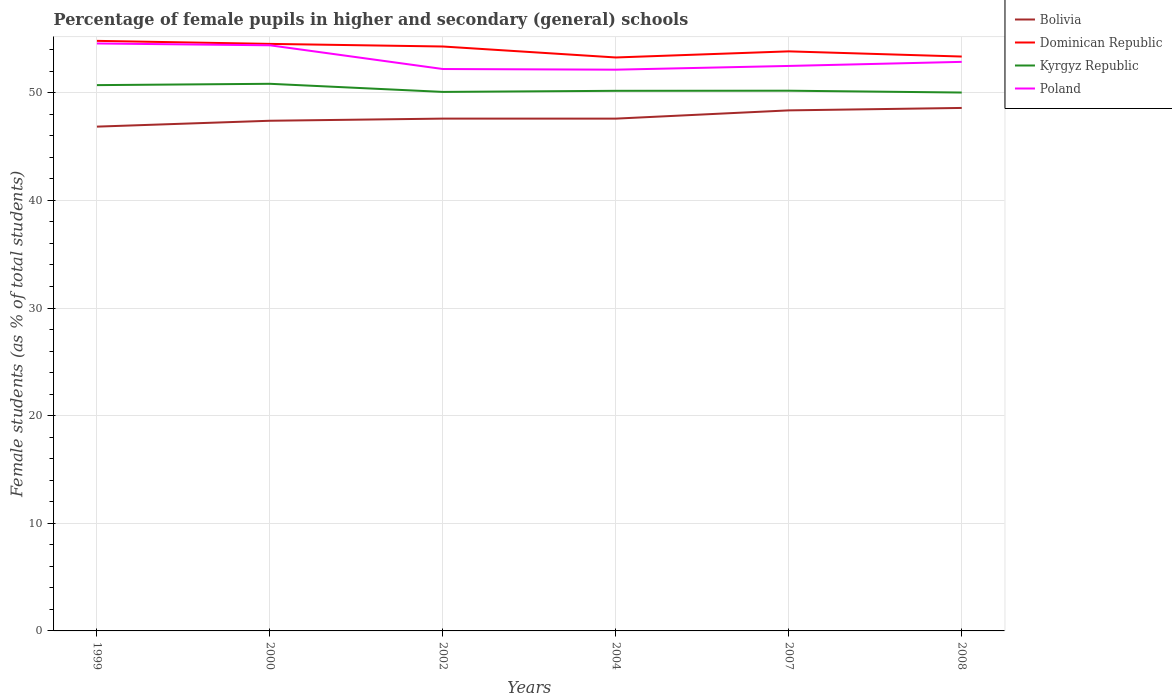Does the line corresponding to Dominican Republic intersect with the line corresponding to Poland?
Provide a succinct answer. No. Across all years, what is the maximum percentage of female pupils in higher and secondary schools in Bolivia?
Keep it short and to the point. 46.85. In which year was the percentage of female pupils in higher and secondary schools in Bolivia maximum?
Offer a very short reply. 1999. What is the total percentage of female pupils in higher and secondary schools in Poland in the graph?
Offer a terse response. 0.06. What is the difference between the highest and the second highest percentage of female pupils in higher and secondary schools in Kyrgyz Republic?
Offer a very short reply. 0.81. Is the percentage of female pupils in higher and secondary schools in Poland strictly greater than the percentage of female pupils in higher and secondary schools in Kyrgyz Republic over the years?
Keep it short and to the point. No. How many lines are there?
Your answer should be compact. 4. How many years are there in the graph?
Provide a short and direct response. 6. What is the difference between two consecutive major ticks on the Y-axis?
Your answer should be compact. 10. Are the values on the major ticks of Y-axis written in scientific E-notation?
Your response must be concise. No. Does the graph contain grids?
Give a very brief answer. Yes. Where does the legend appear in the graph?
Make the answer very short. Top right. How many legend labels are there?
Your answer should be compact. 4. What is the title of the graph?
Keep it short and to the point. Percentage of female pupils in higher and secondary (general) schools. Does "Kyrgyz Republic" appear as one of the legend labels in the graph?
Your answer should be very brief. Yes. What is the label or title of the X-axis?
Your response must be concise. Years. What is the label or title of the Y-axis?
Keep it short and to the point. Female students (as % of total students). What is the Female students (as % of total students) in Bolivia in 1999?
Your answer should be compact. 46.85. What is the Female students (as % of total students) of Dominican Republic in 1999?
Your response must be concise. 54.82. What is the Female students (as % of total students) in Kyrgyz Republic in 1999?
Provide a short and direct response. 50.71. What is the Female students (as % of total students) of Poland in 1999?
Your answer should be compact. 54.58. What is the Female students (as % of total students) of Bolivia in 2000?
Make the answer very short. 47.4. What is the Female students (as % of total students) in Dominican Republic in 2000?
Provide a succinct answer. 54.54. What is the Female students (as % of total students) of Kyrgyz Republic in 2000?
Offer a very short reply. 50.83. What is the Female students (as % of total students) in Poland in 2000?
Ensure brevity in your answer.  54.41. What is the Female students (as % of total students) in Bolivia in 2002?
Provide a succinct answer. 47.6. What is the Female students (as % of total students) in Dominican Republic in 2002?
Offer a terse response. 54.3. What is the Female students (as % of total students) of Kyrgyz Republic in 2002?
Offer a very short reply. 50.08. What is the Female students (as % of total students) in Poland in 2002?
Ensure brevity in your answer.  52.21. What is the Female students (as % of total students) in Bolivia in 2004?
Ensure brevity in your answer.  47.6. What is the Female students (as % of total students) in Dominican Republic in 2004?
Provide a short and direct response. 53.28. What is the Female students (as % of total students) in Kyrgyz Republic in 2004?
Keep it short and to the point. 50.18. What is the Female students (as % of total students) in Poland in 2004?
Give a very brief answer. 52.15. What is the Female students (as % of total students) of Bolivia in 2007?
Offer a terse response. 48.36. What is the Female students (as % of total students) of Dominican Republic in 2007?
Your response must be concise. 53.85. What is the Female students (as % of total students) of Kyrgyz Republic in 2007?
Offer a very short reply. 50.19. What is the Female students (as % of total students) in Poland in 2007?
Offer a very short reply. 52.49. What is the Female students (as % of total students) in Bolivia in 2008?
Provide a short and direct response. 48.59. What is the Female students (as % of total students) in Dominican Republic in 2008?
Offer a terse response. 53.37. What is the Female students (as % of total students) of Kyrgyz Republic in 2008?
Your response must be concise. 50.02. What is the Female students (as % of total students) of Poland in 2008?
Give a very brief answer. 52.87. Across all years, what is the maximum Female students (as % of total students) in Bolivia?
Offer a very short reply. 48.59. Across all years, what is the maximum Female students (as % of total students) of Dominican Republic?
Provide a succinct answer. 54.82. Across all years, what is the maximum Female students (as % of total students) of Kyrgyz Republic?
Provide a succinct answer. 50.83. Across all years, what is the maximum Female students (as % of total students) in Poland?
Offer a very short reply. 54.58. Across all years, what is the minimum Female students (as % of total students) of Bolivia?
Ensure brevity in your answer.  46.85. Across all years, what is the minimum Female students (as % of total students) in Dominican Republic?
Give a very brief answer. 53.28. Across all years, what is the minimum Female students (as % of total students) of Kyrgyz Republic?
Provide a short and direct response. 50.02. Across all years, what is the minimum Female students (as % of total students) of Poland?
Offer a terse response. 52.15. What is the total Female students (as % of total students) in Bolivia in the graph?
Your answer should be very brief. 286.41. What is the total Female students (as % of total students) in Dominican Republic in the graph?
Your answer should be very brief. 324.16. What is the total Female students (as % of total students) of Kyrgyz Republic in the graph?
Make the answer very short. 302.02. What is the total Female students (as % of total students) in Poland in the graph?
Offer a terse response. 318.71. What is the difference between the Female students (as % of total students) in Bolivia in 1999 and that in 2000?
Your answer should be very brief. -0.55. What is the difference between the Female students (as % of total students) in Dominican Republic in 1999 and that in 2000?
Offer a terse response. 0.28. What is the difference between the Female students (as % of total students) of Kyrgyz Republic in 1999 and that in 2000?
Offer a very short reply. -0.12. What is the difference between the Female students (as % of total students) of Poland in 1999 and that in 2000?
Make the answer very short. 0.17. What is the difference between the Female students (as % of total students) in Bolivia in 1999 and that in 2002?
Make the answer very short. -0.75. What is the difference between the Female students (as % of total students) of Dominican Republic in 1999 and that in 2002?
Provide a succinct answer. 0.52. What is the difference between the Female students (as % of total students) in Kyrgyz Republic in 1999 and that in 2002?
Ensure brevity in your answer.  0.63. What is the difference between the Female students (as % of total students) of Poland in 1999 and that in 2002?
Give a very brief answer. 2.37. What is the difference between the Female students (as % of total students) in Bolivia in 1999 and that in 2004?
Your answer should be very brief. -0.74. What is the difference between the Female students (as % of total students) in Dominican Republic in 1999 and that in 2004?
Your answer should be very brief. 1.54. What is the difference between the Female students (as % of total students) of Kyrgyz Republic in 1999 and that in 2004?
Keep it short and to the point. 0.53. What is the difference between the Female students (as % of total students) in Poland in 1999 and that in 2004?
Offer a terse response. 2.43. What is the difference between the Female students (as % of total students) of Bolivia in 1999 and that in 2007?
Your answer should be compact. -1.51. What is the difference between the Female students (as % of total students) in Dominican Republic in 1999 and that in 2007?
Your answer should be very brief. 0.98. What is the difference between the Female students (as % of total students) of Kyrgyz Republic in 1999 and that in 2007?
Ensure brevity in your answer.  0.52. What is the difference between the Female students (as % of total students) of Poland in 1999 and that in 2007?
Offer a terse response. 2.09. What is the difference between the Female students (as % of total students) in Bolivia in 1999 and that in 2008?
Provide a succinct answer. -1.74. What is the difference between the Female students (as % of total students) in Dominican Republic in 1999 and that in 2008?
Your answer should be very brief. 1.46. What is the difference between the Female students (as % of total students) in Kyrgyz Republic in 1999 and that in 2008?
Make the answer very short. 0.69. What is the difference between the Female students (as % of total students) of Poland in 1999 and that in 2008?
Ensure brevity in your answer.  1.71. What is the difference between the Female students (as % of total students) in Bolivia in 2000 and that in 2002?
Make the answer very short. -0.2. What is the difference between the Female students (as % of total students) of Dominican Republic in 2000 and that in 2002?
Ensure brevity in your answer.  0.24. What is the difference between the Female students (as % of total students) of Kyrgyz Republic in 2000 and that in 2002?
Ensure brevity in your answer.  0.75. What is the difference between the Female students (as % of total students) of Poland in 2000 and that in 2002?
Offer a terse response. 2.2. What is the difference between the Female students (as % of total students) of Bolivia in 2000 and that in 2004?
Your answer should be compact. -0.2. What is the difference between the Female students (as % of total students) of Dominican Republic in 2000 and that in 2004?
Provide a short and direct response. 1.26. What is the difference between the Female students (as % of total students) of Kyrgyz Republic in 2000 and that in 2004?
Your answer should be very brief. 0.65. What is the difference between the Female students (as % of total students) of Poland in 2000 and that in 2004?
Your response must be concise. 2.27. What is the difference between the Female students (as % of total students) of Bolivia in 2000 and that in 2007?
Your answer should be very brief. -0.96. What is the difference between the Female students (as % of total students) in Dominican Republic in 2000 and that in 2007?
Offer a terse response. 0.69. What is the difference between the Female students (as % of total students) of Kyrgyz Republic in 2000 and that in 2007?
Ensure brevity in your answer.  0.64. What is the difference between the Female students (as % of total students) of Poland in 2000 and that in 2007?
Ensure brevity in your answer.  1.92. What is the difference between the Female students (as % of total students) of Bolivia in 2000 and that in 2008?
Offer a terse response. -1.19. What is the difference between the Female students (as % of total students) in Dominican Republic in 2000 and that in 2008?
Provide a short and direct response. 1.18. What is the difference between the Female students (as % of total students) in Kyrgyz Republic in 2000 and that in 2008?
Your answer should be very brief. 0.81. What is the difference between the Female students (as % of total students) in Poland in 2000 and that in 2008?
Offer a terse response. 1.54. What is the difference between the Female students (as % of total students) in Bolivia in 2002 and that in 2004?
Provide a succinct answer. 0. What is the difference between the Female students (as % of total students) of Dominican Republic in 2002 and that in 2004?
Provide a short and direct response. 1.02. What is the difference between the Female students (as % of total students) in Kyrgyz Republic in 2002 and that in 2004?
Your answer should be very brief. -0.1. What is the difference between the Female students (as % of total students) of Poland in 2002 and that in 2004?
Keep it short and to the point. 0.06. What is the difference between the Female students (as % of total students) of Bolivia in 2002 and that in 2007?
Provide a succinct answer. -0.76. What is the difference between the Female students (as % of total students) in Dominican Republic in 2002 and that in 2007?
Provide a short and direct response. 0.45. What is the difference between the Female students (as % of total students) in Kyrgyz Republic in 2002 and that in 2007?
Your response must be concise. -0.11. What is the difference between the Female students (as % of total students) in Poland in 2002 and that in 2007?
Give a very brief answer. -0.29. What is the difference between the Female students (as % of total students) in Bolivia in 2002 and that in 2008?
Keep it short and to the point. -0.99. What is the difference between the Female students (as % of total students) in Dominican Republic in 2002 and that in 2008?
Offer a terse response. 0.93. What is the difference between the Female students (as % of total students) of Kyrgyz Republic in 2002 and that in 2008?
Offer a terse response. 0.06. What is the difference between the Female students (as % of total students) of Poland in 2002 and that in 2008?
Provide a short and direct response. -0.67. What is the difference between the Female students (as % of total students) in Bolivia in 2004 and that in 2007?
Offer a terse response. -0.77. What is the difference between the Female students (as % of total students) of Dominican Republic in 2004 and that in 2007?
Your answer should be compact. -0.57. What is the difference between the Female students (as % of total students) in Kyrgyz Republic in 2004 and that in 2007?
Keep it short and to the point. -0.01. What is the difference between the Female students (as % of total students) in Poland in 2004 and that in 2007?
Make the answer very short. -0.35. What is the difference between the Female students (as % of total students) of Bolivia in 2004 and that in 2008?
Keep it short and to the point. -0.99. What is the difference between the Female students (as % of total students) of Dominican Republic in 2004 and that in 2008?
Make the answer very short. -0.09. What is the difference between the Female students (as % of total students) in Kyrgyz Republic in 2004 and that in 2008?
Keep it short and to the point. 0.16. What is the difference between the Female students (as % of total students) of Poland in 2004 and that in 2008?
Offer a very short reply. -0.73. What is the difference between the Female students (as % of total students) in Bolivia in 2007 and that in 2008?
Give a very brief answer. -0.23. What is the difference between the Female students (as % of total students) in Dominican Republic in 2007 and that in 2008?
Ensure brevity in your answer.  0.48. What is the difference between the Female students (as % of total students) in Kyrgyz Republic in 2007 and that in 2008?
Your response must be concise. 0.17. What is the difference between the Female students (as % of total students) in Poland in 2007 and that in 2008?
Provide a short and direct response. -0.38. What is the difference between the Female students (as % of total students) of Bolivia in 1999 and the Female students (as % of total students) of Dominican Republic in 2000?
Offer a very short reply. -7.69. What is the difference between the Female students (as % of total students) of Bolivia in 1999 and the Female students (as % of total students) of Kyrgyz Republic in 2000?
Provide a short and direct response. -3.98. What is the difference between the Female students (as % of total students) in Bolivia in 1999 and the Female students (as % of total students) in Poland in 2000?
Ensure brevity in your answer.  -7.56. What is the difference between the Female students (as % of total students) of Dominican Republic in 1999 and the Female students (as % of total students) of Kyrgyz Republic in 2000?
Keep it short and to the point. 3.99. What is the difference between the Female students (as % of total students) of Dominican Republic in 1999 and the Female students (as % of total students) of Poland in 2000?
Provide a short and direct response. 0.41. What is the difference between the Female students (as % of total students) in Kyrgyz Republic in 1999 and the Female students (as % of total students) in Poland in 2000?
Make the answer very short. -3.7. What is the difference between the Female students (as % of total students) of Bolivia in 1999 and the Female students (as % of total students) of Dominican Republic in 2002?
Your answer should be very brief. -7.44. What is the difference between the Female students (as % of total students) of Bolivia in 1999 and the Female students (as % of total students) of Kyrgyz Republic in 2002?
Provide a short and direct response. -3.23. What is the difference between the Female students (as % of total students) in Bolivia in 1999 and the Female students (as % of total students) in Poland in 2002?
Offer a very short reply. -5.35. What is the difference between the Female students (as % of total students) in Dominican Republic in 1999 and the Female students (as % of total students) in Kyrgyz Republic in 2002?
Offer a very short reply. 4.74. What is the difference between the Female students (as % of total students) in Dominican Republic in 1999 and the Female students (as % of total students) in Poland in 2002?
Your answer should be compact. 2.62. What is the difference between the Female students (as % of total students) of Kyrgyz Republic in 1999 and the Female students (as % of total students) of Poland in 2002?
Your response must be concise. -1.5. What is the difference between the Female students (as % of total students) of Bolivia in 1999 and the Female students (as % of total students) of Dominican Republic in 2004?
Your answer should be very brief. -6.43. What is the difference between the Female students (as % of total students) of Bolivia in 1999 and the Female students (as % of total students) of Kyrgyz Republic in 2004?
Keep it short and to the point. -3.33. What is the difference between the Female students (as % of total students) of Bolivia in 1999 and the Female students (as % of total students) of Poland in 2004?
Provide a short and direct response. -5.29. What is the difference between the Female students (as % of total students) in Dominican Republic in 1999 and the Female students (as % of total students) in Kyrgyz Republic in 2004?
Keep it short and to the point. 4.64. What is the difference between the Female students (as % of total students) of Dominican Republic in 1999 and the Female students (as % of total students) of Poland in 2004?
Make the answer very short. 2.68. What is the difference between the Female students (as % of total students) of Kyrgyz Republic in 1999 and the Female students (as % of total students) of Poland in 2004?
Make the answer very short. -1.44. What is the difference between the Female students (as % of total students) in Bolivia in 1999 and the Female students (as % of total students) in Dominican Republic in 2007?
Your answer should be compact. -6.99. What is the difference between the Female students (as % of total students) in Bolivia in 1999 and the Female students (as % of total students) in Kyrgyz Republic in 2007?
Make the answer very short. -3.34. What is the difference between the Female students (as % of total students) in Bolivia in 1999 and the Female students (as % of total students) in Poland in 2007?
Make the answer very short. -5.64. What is the difference between the Female students (as % of total students) of Dominican Republic in 1999 and the Female students (as % of total students) of Kyrgyz Republic in 2007?
Your answer should be compact. 4.63. What is the difference between the Female students (as % of total students) in Dominican Republic in 1999 and the Female students (as % of total students) in Poland in 2007?
Your answer should be compact. 2.33. What is the difference between the Female students (as % of total students) of Kyrgyz Republic in 1999 and the Female students (as % of total students) of Poland in 2007?
Keep it short and to the point. -1.78. What is the difference between the Female students (as % of total students) in Bolivia in 1999 and the Female students (as % of total students) in Dominican Republic in 2008?
Make the answer very short. -6.51. What is the difference between the Female students (as % of total students) of Bolivia in 1999 and the Female students (as % of total students) of Kyrgyz Republic in 2008?
Make the answer very short. -3.17. What is the difference between the Female students (as % of total students) of Bolivia in 1999 and the Female students (as % of total students) of Poland in 2008?
Provide a succinct answer. -6.02. What is the difference between the Female students (as % of total students) in Dominican Republic in 1999 and the Female students (as % of total students) in Kyrgyz Republic in 2008?
Your response must be concise. 4.8. What is the difference between the Female students (as % of total students) in Dominican Republic in 1999 and the Female students (as % of total students) in Poland in 2008?
Provide a short and direct response. 1.95. What is the difference between the Female students (as % of total students) in Kyrgyz Republic in 1999 and the Female students (as % of total students) in Poland in 2008?
Keep it short and to the point. -2.16. What is the difference between the Female students (as % of total students) of Bolivia in 2000 and the Female students (as % of total students) of Dominican Republic in 2002?
Make the answer very short. -6.9. What is the difference between the Female students (as % of total students) of Bolivia in 2000 and the Female students (as % of total students) of Kyrgyz Republic in 2002?
Provide a succinct answer. -2.68. What is the difference between the Female students (as % of total students) in Bolivia in 2000 and the Female students (as % of total students) in Poland in 2002?
Provide a succinct answer. -4.81. What is the difference between the Female students (as % of total students) in Dominican Republic in 2000 and the Female students (as % of total students) in Kyrgyz Republic in 2002?
Ensure brevity in your answer.  4.46. What is the difference between the Female students (as % of total students) of Dominican Republic in 2000 and the Female students (as % of total students) of Poland in 2002?
Keep it short and to the point. 2.34. What is the difference between the Female students (as % of total students) of Kyrgyz Republic in 2000 and the Female students (as % of total students) of Poland in 2002?
Your answer should be compact. -1.37. What is the difference between the Female students (as % of total students) in Bolivia in 2000 and the Female students (as % of total students) in Dominican Republic in 2004?
Your response must be concise. -5.88. What is the difference between the Female students (as % of total students) of Bolivia in 2000 and the Female students (as % of total students) of Kyrgyz Republic in 2004?
Your response must be concise. -2.78. What is the difference between the Female students (as % of total students) in Bolivia in 2000 and the Female students (as % of total students) in Poland in 2004?
Provide a succinct answer. -4.75. What is the difference between the Female students (as % of total students) in Dominican Republic in 2000 and the Female students (as % of total students) in Kyrgyz Republic in 2004?
Offer a very short reply. 4.36. What is the difference between the Female students (as % of total students) of Dominican Republic in 2000 and the Female students (as % of total students) of Poland in 2004?
Keep it short and to the point. 2.4. What is the difference between the Female students (as % of total students) in Kyrgyz Republic in 2000 and the Female students (as % of total students) in Poland in 2004?
Your answer should be very brief. -1.31. What is the difference between the Female students (as % of total students) of Bolivia in 2000 and the Female students (as % of total students) of Dominican Republic in 2007?
Provide a short and direct response. -6.45. What is the difference between the Female students (as % of total students) in Bolivia in 2000 and the Female students (as % of total students) in Kyrgyz Republic in 2007?
Ensure brevity in your answer.  -2.79. What is the difference between the Female students (as % of total students) of Bolivia in 2000 and the Female students (as % of total students) of Poland in 2007?
Your answer should be very brief. -5.09. What is the difference between the Female students (as % of total students) of Dominican Republic in 2000 and the Female students (as % of total students) of Kyrgyz Republic in 2007?
Give a very brief answer. 4.35. What is the difference between the Female students (as % of total students) of Dominican Republic in 2000 and the Female students (as % of total students) of Poland in 2007?
Your response must be concise. 2.05. What is the difference between the Female students (as % of total students) in Kyrgyz Republic in 2000 and the Female students (as % of total students) in Poland in 2007?
Provide a short and direct response. -1.66. What is the difference between the Female students (as % of total students) of Bolivia in 2000 and the Female students (as % of total students) of Dominican Republic in 2008?
Your response must be concise. -5.97. What is the difference between the Female students (as % of total students) of Bolivia in 2000 and the Female students (as % of total students) of Kyrgyz Republic in 2008?
Keep it short and to the point. -2.62. What is the difference between the Female students (as % of total students) in Bolivia in 2000 and the Female students (as % of total students) in Poland in 2008?
Keep it short and to the point. -5.47. What is the difference between the Female students (as % of total students) in Dominican Republic in 2000 and the Female students (as % of total students) in Kyrgyz Republic in 2008?
Ensure brevity in your answer.  4.52. What is the difference between the Female students (as % of total students) in Dominican Republic in 2000 and the Female students (as % of total students) in Poland in 2008?
Your response must be concise. 1.67. What is the difference between the Female students (as % of total students) in Kyrgyz Republic in 2000 and the Female students (as % of total students) in Poland in 2008?
Provide a short and direct response. -2.04. What is the difference between the Female students (as % of total students) in Bolivia in 2002 and the Female students (as % of total students) in Dominican Republic in 2004?
Provide a short and direct response. -5.68. What is the difference between the Female students (as % of total students) of Bolivia in 2002 and the Female students (as % of total students) of Kyrgyz Republic in 2004?
Your response must be concise. -2.58. What is the difference between the Female students (as % of total students) in Bolivia in 2002 and the Female students (as % of total students) in Poland in 2004?
Your answer should be compact. -4.55. What is the difference between the Female students (as % of total students) in Dominican Republic in 2002 and the Female students (as % of total students) in Kyrgyz Republic in 2004?
Give a very brief answer. 4.12. What is the difference between the Female students (as % of total students) of Dominican Republic in 2002 and the Female students (as % of total students) of Poland in 2004?
Your answer should be very brief. 2.15. What is the difference between the Female students (as % of total students) in Kyrgyz Republic in 2002 and the Female students (as % of total students) in Poland in 2004?
Offer a terse response. -2.07. What is the difference between the Female students (as % of total students) of Bolivia in 2002 and the Female students (as % of total students) of Dominican Republic in 2007?
Your answer should be very brief. -6.25. What is the difference between the Female students (as % of total students) in Bolivia in 2002 and the Female students (as % of total students) in Kyrgyz Republic in 2007?
Offer a very short reply. -2.59. What is the difference between the Female students (as % of total students) in Bolivia in 2002 and the Female students (as % of total students) in Poland in 2007?
Offer a very short reply. -4.89. What is the difference between the Female students (as % of total students) of Dominican Republic in 2002 and the Female students (as % of total students) of Kyrgyz Republic in 2007?
Make the answer very short. 4.11. What is the difference between the Female students (as % of total students) of Dominican Republic in 2002 and the Female students (as % of total students) of Poland in 2007?
Keep it short and to the point. 1.81. What is the difference between the Female students (as % of total students) in Kyrgyz Republic in 2002 and the Female students (as % of total students) in Poland in 2007?
Your answer should be very brief. -2.41. What is the difference between the Female students (as % of total students) in Bolivia in 2002 and the Female students (as % of total students) in Dominican Republic in 2008?
Offer a very short reply. -5.77. What is the difference between the Female students (as % of total students) in Bolivia in 2002 and the Female students (as % of total students) in Kyrgyz Republic in 2008?
Provide a succinct answer. -2.42. What is the difference between the Female students (as % of total students) in Bolivia in 2002 and the Female students (as % of total students) in Poland in 2008?
Provide a short and direct response. -5.27. What is the difference between the Female students (as % of total students) of Dominican Republic in 2002 and the Female students (as % of total students) of Kyrgyz Republic in 2008?
Offer a terse response. 4.28. What is the difference between the Female students (as % of total students) in Dominican Republic in 2002 and the Female students (as % of total students) in Poland in 2008?
Your response must be concise. 1.43. What is the difference between the Female students (as % of total students) of Kyrgyz Republic in 2002 and the Female students (as % of total students) of Poland in 2008?
Your response must be concise. -2.79. What is the difference between the Female students (as % of total students) of Bolivia in 2004 and the Female students (as % of total students) of Dominican Republic in 2007?
Your answer should be compact. -6.25. What is the difference between the Female students (as % of total students) of Bolivia in 2004 and the Female students (as % of total students) of Kyrgyz Republic in 2007?
Your response must be concise. -2.59. What is the difference between the Female students (as % of total students) in Bolivia in 2004 and the Female students (as % of total students) in Poland in 2007?
Ensure brevity in your answer.  -4.9. What is the difference between the Female students (as % of total students) of Dominican Republic in 2004 and the Female students (as % of total students) of Kyrgyz Republic in 2007?
Make the answer very short. 3.09. What is the difference between the Female students (as % of total students) in Dominican Republic in 2004 and the Female students (as % of total students) in Poland in 2007?
Give a very brief answer. 0.79. What is the difference between the Female students (as % of total students) of Kyrgyz Republic in 2004 and the Female students (as % of total students) of Poland in 2007?
Your answer should be compact. -2.31. What is the difference between the Female students (as % of total students) in Bolivia in 2004 and the Female students (as % of total students) in Dominican Republic in 2008?
Your answer should be very brief. -5.77. What is the difference between the Female students (as % of total students) in Bolivia in 2004 and the Female students (as % of total students) in Kyrgyz Republic in 2008?
Offer a very short reply. -2.42. What is the difference between the Female students (as % of total students) in Bolivia in 2004 and the Female students (as % of total students) in Poland in 2008?
Give a very brief answer. -5.27. What is the difference between the Female students (as % of total students) in Dominican Republic in 2004 and the Female students (as % of total students) in Kyrgyz Republic in 2008?
Give a very brief answer. 3.26. What is the difference between the Female students (as % of total students) in Dominican Republic in 2004 and the Female students (as % of total students) in Poland in 2008?
Your answer should be very brief. 0.41. What is the difference between the Female students (as % of total students) in Kyrgyz Republic in 2004 and the Female students (as % of total students) in Poland in 2008?
Your answer should be very brief. -2.69. What is the difference between the Female students (as % of total students) in Bolivia in 2007 and the Female students (as % of total students) in Dominican Republic in 2008?
Offer a very short reply. -5. What is the difference between the Female students (as % of total students) in Bolivia in 2007 and the Female students (as % of total students) in Kyrgyz Republic in 2008?
Keep it short and to the point. -1.66. What is the difference between the Female students (as % of total students) in Bolivia in 2007 and the Female students (as % of total students) in Poland in 2008?
Your answer should be very brief. -4.51. What is the difference between the Female students (as % of total students) in Dominican Republic in 2007 and the Female students (as % of total students) in Kyrgyz Republic in 2008?
Provide a succinct answer. 3.83. What is the difference between the Female students (as % of total students) of Dominican Republic in 2007 and the Female students (as % of total students) of Poland in 2008?
Offer a terse response. 0.98. What is the difference between the Female students (as % of total students) of Kyrgyz Republic in 2007 and the Female students (as % of total students) of Poland in 2008?
Ensure brevity in your answer.  -2.68. What is the average Female students (as % of total students) of Bolivia per year?
Your response must be concise. 47.73. What is the average Female students (as % of total students) in Dominican Republic per year?
Offer a very short reply. 54.03. What is the average Female students (as % of total students) of Kyrgyz Republic per year?
Your answer should be compact. 50.34. What is the average Female students (as % of total students) of Poland per year?
Provide a short and direct response. 53.12. In the year 1999, what is the difference between the Female students (as % of total students) in Bolivia and Female students (as % of total students) in Dominican Republic?
Offer a terse response. -7.97. In the year 1999, what is the difference between the Female students (as % of total students) of Bolivia and Female students (as % of total students) of Kyrgyz Republic?
Your response must be concise. -3.86. In the year 1999, what is the difference between the Female students (as % of total students) in Bolivia and Female students (as % of total students) in Poland?
Your answer should be very brief. -7.73. In the year 1999, what is the difference between the Female students (as % of total students) of Dominican Republic and Female students (as % of total students) of Kyrgyz Republic?
Your answer should be compact. 4.11. In the year 1999, what is the difference between the Female students (as % of total students) in Dominican Republic and Female students (as % of total students) in Poland?
Offer a very short reply. 0.24. In the year 1999, what is the difference between the Female students (as % of total students) of Kyrgyz Republic and Female students (as % of total students) of Poland?
Keep it short and to the point. -3.87. In the year 2000, what is the difference between the Female students (as % of total students) of Bolivia and Female students (as % of total students) of Dominican Republic?
Provide a succinct answer. -7.14. In the year 2000, what is the difference between the Female students (as % of total students) of Bolivia and Female students (as % of total students) of Kyrgyz Republic?
Offer a very short reply. -3.43. In the year 2000, what is the difference between the Female students (as % of total students) in Bolivia and Female students (as % of total students) in Poland?
Your answer should be compact. -7.01. In the year 2000, what is the difference between the Female students (as % of total students) of Dominican Republic and Female students (as % of total students) of Kyrgyz Republic?
Keep it short and to the point. 3.71. In the year 2000, what is the difference between the Female students (as % of total students) in Dominican Republic and Female students (as % of total students) in Poland?
Provide a succinct answer. 0.13. In the year 2000, what is the difference between the Female students (as % of total students) in Kyrgyz Republic and Female students (as % of total students) in Poland?
Ensure brevity in your answer.  -3.58. In the year 2002, what is the difference between the Female students (as % of total students) of Bolivia and Female students (as % of total students) of Dominican Republic?
Keep it short and to the point. -6.7. In the year 2002, what is the difference between the Female students (as % of total students) in Bolivia and Female students (as % of total students) in Kyrgyz Republic?
Offer a very short reply. -2.48. In the year 2002, what is the difference between the Female students (as % of total students) of Bolivia and Female students (as % of total students) of Poland?
Your answer should be very brief. -4.61. In the year 2002, what is the difference between the Female students (as % of total students) in Dominican Republic and Female students (as % of total students) in Kyrgyz Republic?
Offer a terse response. 4.22. In the year 2002, what is the difference between the Female students (as % of total students) in Dominican Republic and Female students (as % of total students) in Poland?
Ensure brevity in your answer.  2.09. In the year 2002, what is the difference between the Female students (as % of total students) of Kyrgyz Republic and Female students (as % of total students) of Poland?
Ensure brevity in your answer.  -2.13. In the year 2004, what is the difference between the Female students (as % of total students) of Bolivia and Female students (as % of total students) of Dominican Republic?
Give a very brief answer. -5.68. In the year 2004, what is the difference between the Female students (as % of total students) of Bolivia and Female students (as % of total students) of Kyrgyz Republic?
Your response must be concise. -2.58. In the year 2004, what is the difference between the Female students (as % of total students) in Bolivia and Female students (as % of total students) in Poland?
Give a very brief answer. -4.55. In the year 2004, what is the difference between the Female students (as % of total students) in Dominican Republic and Female students (as % of total students) in Kyrgyz Republic?
Offer a very short reply. 3.1. In the year 2004, what is the difference between the Female students (as % of total students) in Dominican Republic and Female students (as % of total students) in Poland?
Your response must be concise. 1.13. In the year 2004, what is the difference between the Female students (as % of total students) of Kyrgyz Republic and Female students (as % of total students) of Poland?
Ensure brevity in your answer.  -1.96. In the year 2007, what is the difference between the Female students (as % of total students) in Bolivia and Female students (as % of total students) in Dominican Republic?
Ensure brevity in your answer.  -5.48. In the year 2007, what is the difference between the Female students (as % of total students) in Bolivia and Female students (as % of total students) in Kyrgyz Republic?
Ensure brevity in your answer.  -1.83. In the year 2007, what is the difference between the Female students (as % of total students) of Bolivia and Female students (as % of total students) of Poland?
Provide a succinct answer. -4.13. In the year 2007, what is the difference between the Female students (as % of total students) of Dominican Republic and Female students (as % of total students) of Kyrgyz Republic?
Keep it short and to the point. 3.66. In the year 2007, what is the difference between the Female students (as % of total students) in Dominican Republic and Female students (as % of total students) in Poland?
Offer a very short reply. 1.35. In the year 2007, what is the difference between the Female students (as % of total students) in Kyrgyz Republic and Female students (as % of total students) in Poland?
Offer a terse response. -2.3. In the year 2008, what is the difference between the Female students (as % of total students) in Bolivia and Female students (as % of total students) in Dominican Republic?
Make the answer very short. -4.78. In the year 2008, what is the difference between the Female students (as % of total students) of Bolivia and Female students (as % of total students) of Kyrgyz Republic?
Ensure brevity in your answer.  -1.43. In the year 2008, what is the difference between the Female students (as % of total students) of Bolivia and Female students (as % of total students) of Poland?
Your response must be concise. -4.28. In the year 2008, what is the difference between the Female students (as % of total students) in Dominican Republic and Female students (as % of total students) in Kyrgyz Republic?
Offer a terse response. 3.34. In the year 2008, what is the difference between the Female students (as % of total students) in Dominican Republic and Female students (as % of total students) in Poland?
Make the answer very short. 0.49. In the year 2008, what is the difference between the Female students (as % of total students) in Kyrgyz Republic and Female students (as % of total students) in Poland?
Provide a succinct answer. -2.85. What is the ratio of the Female students (as % of total students) in Dominican Republic in 1999 to that in 2000?
Offer a terse response. 1.01. What is the ratio of the Female students (as % of total students) in Kyrgyz Republic in 1999 to that in 2000?
Your answer should be very brief. 1. What is the ratio of the Female students (as % of total students) of Poland in 1999 to that in 2000?
Provide a succinct answer. 1. What is the ratio of the Female students (as % of total students) in Bolivia in 1999 to that in 2002?
Give a very brief answer. 0.98. What is the ratio of the Female students (as % of total students) of Dominican Republic in 1999 to that in 2002?
Offer a very short reply. 1.01. What is the ratio of the Female students (as % of total students) in Kyrgyz Republic in 1999 to that in 2002?
Offer a terse response. 1.01. What is the ratio of the Female students (as % of total students) in Poland in 1999 to that in 2002?
Keep it short and to the point. 1.05. What is the ratio of the Female students (as % of total students) of Bolivia in 1999 to that in 2004?
Ensure brevity in your answer.  0.98. What is the ratio of the Female students (as % of total students) in Dominican Republic in 1999 to that in 2004?
Offer a terse response. 1.03. What is the ratio of the Female students (as % of total students) of Kyrgyz Republic in 1999 to that in 2004?
Your answer should be very brief. 1.01. What is the ratio of the Female students (as % of total students) in Poland in 1999 to that in 2004?
Ensure brevity in your answer.  1.05. What is the ratio of the Female students (as % of total students) in Bolivia in 1999 to that in 2007?
Offer a terse response. 0.97. What is the ratio of the Female students (as % of total students) of Dominican Republic in 1999 to that in 2007?
Offer a terse response. 1.02. What is the ratio of the Female students (as % of total students) in Kyrgyz Republic in 1999 to that in 2007?
Your answer should be compact. 1.01. What is the ratio of the Female students (as % of total students) of Poland in 1999 to that in 2007?
Keep it short and to the point. 1.04. What is the ratio of the Female students (as % of total students) in Bolivia in 1999 to that in 2008?
Provide a succinct answer. 0.96. What is the ratio of the Female students (as % of total students) of Dominican Republic in 1999 to that in 2008?
Give a very brief answer. 1.03. What is the ratio of the Female students (as % of total students) of Kyrgyz Republic in 1999 to that in 2008?
Give a very brief answer. 1.01. What is the ratio of the Female students (as % of total students) of Poland in 1999 to that in 2008?
Ensure brevity in your answer.  1.03. What is the ratio of the Female students (as % of total students) in Dominican Republic in 2000 to that in 2002?
Offer a very short reply. 1. What is the ratio of the Female students (as % of total students) of Kyrgyz Republic in 2000 to that in 2002?
Your response must be concise. 1.01. What is the ratio of the Female students (as % of total students) of Poland in 2000 to that in 2002?
Offer a very short reply. 1.04. What is the ratio of the Female students (as % of total students) in Bolivia in 2000 to that in 2004?
Provide a succinct answer. 1. What is the ratio of the Female students (as % of total students) of Dominican Republic in 2000 to that in 2004?
Your answer should be compact. 1.02. What is the ratio of the Female students (as % of total students) of Poland in 2000 to that in 2004?
Ensure brevity in your answer.  1.04. What is the ratio of the Female students (as % of total students) in Bolivia in 2000 to that in 2007?
Provide a short and direct response. 0.98. What is the ratio of the Female students (as % of total students) of Dominican Republic in 2000 to that in 2007?
Ensure brevity in your answer.  1.01. What is the ratio of the Female students (as % of total students) in Kyrgyz Republic in 2000 to that in 2007?
Provide a succinct answer. 1.01. What is the ratio of the Female students (as % of total students) in Poland in 2000 to that in 2007?
Make the answer very short. 1.04. What is the ratio of the Female students (as % of total students) in Bolivia in 2000 to that in 2008?
Provide a succinct answer. 0.98. What is the ratio of the Female students (as % of total students) in Dominican Republic in 2000 to that in 2008?
Provide a succinct answer. 1.02. What is the ratio of the Female students (as % of total students) in Kyrgyz Republic in 2000 to that in 2008?
Offer a very short reply. 1.02. What is the ratio of the Female students (as % of total students) in Poland in 2000 to that in 2008?
Your answer should be very brief. 1.03. What is the ratio of the Female students (as % of total students) in Dominican Republic in 2002 to that in 2004?
Offer a terse response. 1.02. What is the ratio of the Female students (as % of total students) of Bolivia in 2002 to that in 2007?
Offer a terse response. 0.98. What is the ratio of the Female students (as % of total students) of Dominican Republic in 2002 to that in 2007?
Make the answer very short. 1.01. What is the ratio of the Female students (as % of total students) in Kyrgyz Republic in 2002 to that in 2007?
Keep it short and to the point. 1. What is the ratio of the Female students (as % of total students) in Poland in 2002 to that in 2007?
Offer a terse response. 0.99. What is the ratio of the Female students (as % of total students) of Bolivia in 2002 to that in 2008?
Your answer should be compact. 0.98. What is the ratio of the Female students (as % of total students) of Dominican Republic in 2002 to that in 2008?
Your answer should be compact. 1.02. What is the ratio of the Female students (as % of total students) of Kyrgyz Republic in 2002 to that in 2008?
Ensure brevity in your answer.  1. What is the ratio of the Female students (as % of total students) of Poland in 2002 to that in 2008?
Make the answer very short. 0.99. What is the ratio of the Female students (as % of total students) of Bolivia in 2004 to that in 2007?
Your response must be concise. 0.98. What is the ratio of the Female students (as % of total students) of Dominican Republic in 2004 to that in 2007?
Your answer should be very brief. 0.99. What is the ratio of the Female students (as % of total students) in Bolivia in 2004 to that in 2008?
Keep it short and to the point. 0.98. What is the ratio of the Female students (as % of total students) of Poland in 2004 to that in 2008?
Offer a terse response. 0.99. What is the ratio of the Female students (as % of total students) in Dominican Republic in 2007 to that in 2008?
Your response must be concise. 1.01. What is the difference between the highest and the second highest Female students (as % of total students) in Bolivia?
Provide a succinct answer. 0.23. What is the difference between the highest and the second highest Female students (as % of total students) in Dominican Republic?
Provide a succinct answer. 0.28. What is the difference between the highest and the second highest Female students (as % of total students) in Kyrgyz Republic?
Provide a succinct answer. 0.12. What is the difference between the highest and the second highest Female students (as % of total students) of Poland?
Provide a succinct answer. 0.17. What is the difference between the highest and the lowest Female students (as % of total students) of Bolivia?
Your response must be concise. 1.74. What is the difference between the highest and the lowest Female students (as % of total students) in Dominican Republic?
Provide a short and direct response. 1.54. What is the difference between the highest and the lowest Female students (as % of total students) of Kyrgyz Republic?
Keep it short and to the point. 0.81. What is the difference between the highest and the lowest Female students (as % of total students) of Poland?
Make the answer very short. 2.43. 